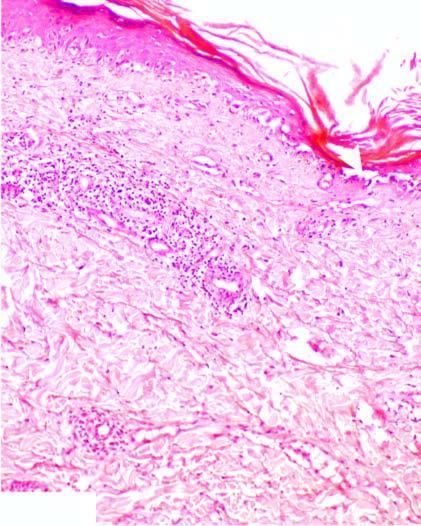s there hyperkeratosis and follicular plugging?
Answer the question using a single word or phrase. Yes 